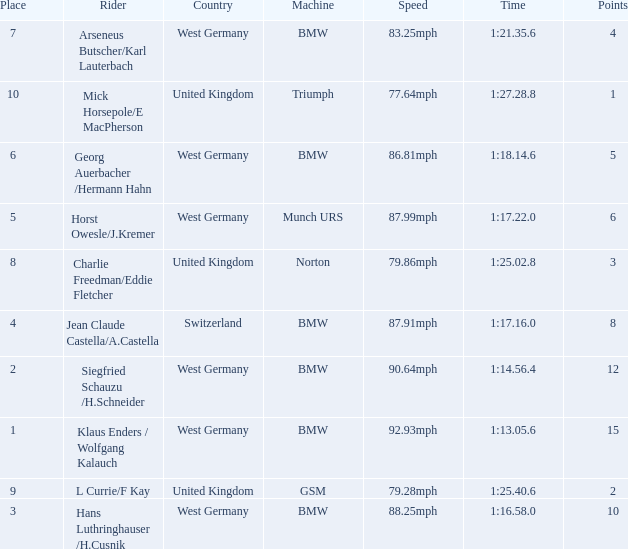Which places have points larger than 10? None. 